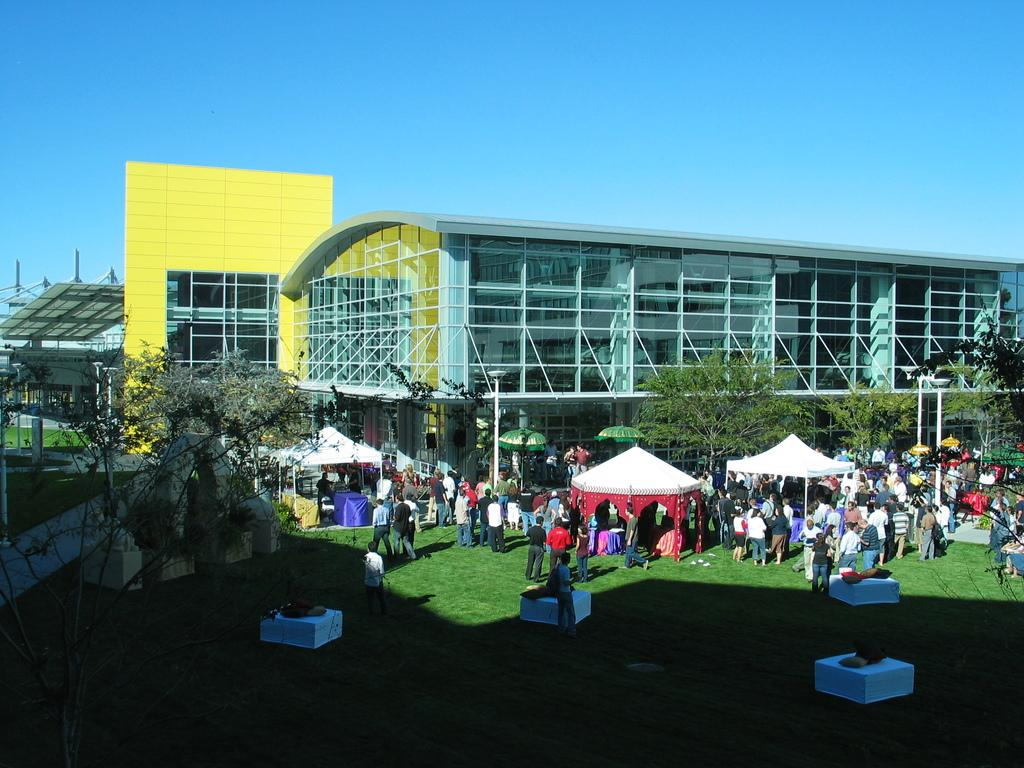What type of structures can be seen in the image? There are buildings in the image. What natural elements are present in the image? There are trees in the image. What temporary shelters can be seen in the image? There are tents in the image. What are the people in the image doing? There are people on the grass in the image. What type of drink is being served in the tents in the image? There is no mention of any drinks, including eggnog, being served in the image. Can you compare the height of the trees to the height of the buildings in the image? The provided facts do not include any information about the height of the trees or buildings, so a comparison cannot be made. 